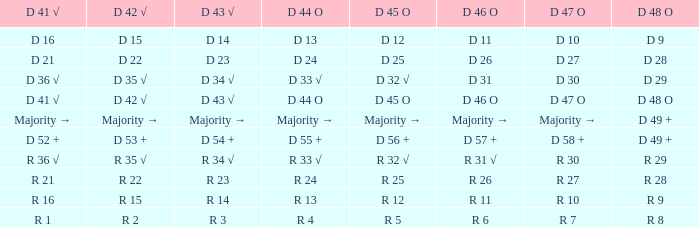Name the D 45 O with D 46 O of r 31 √ R 32 √. 